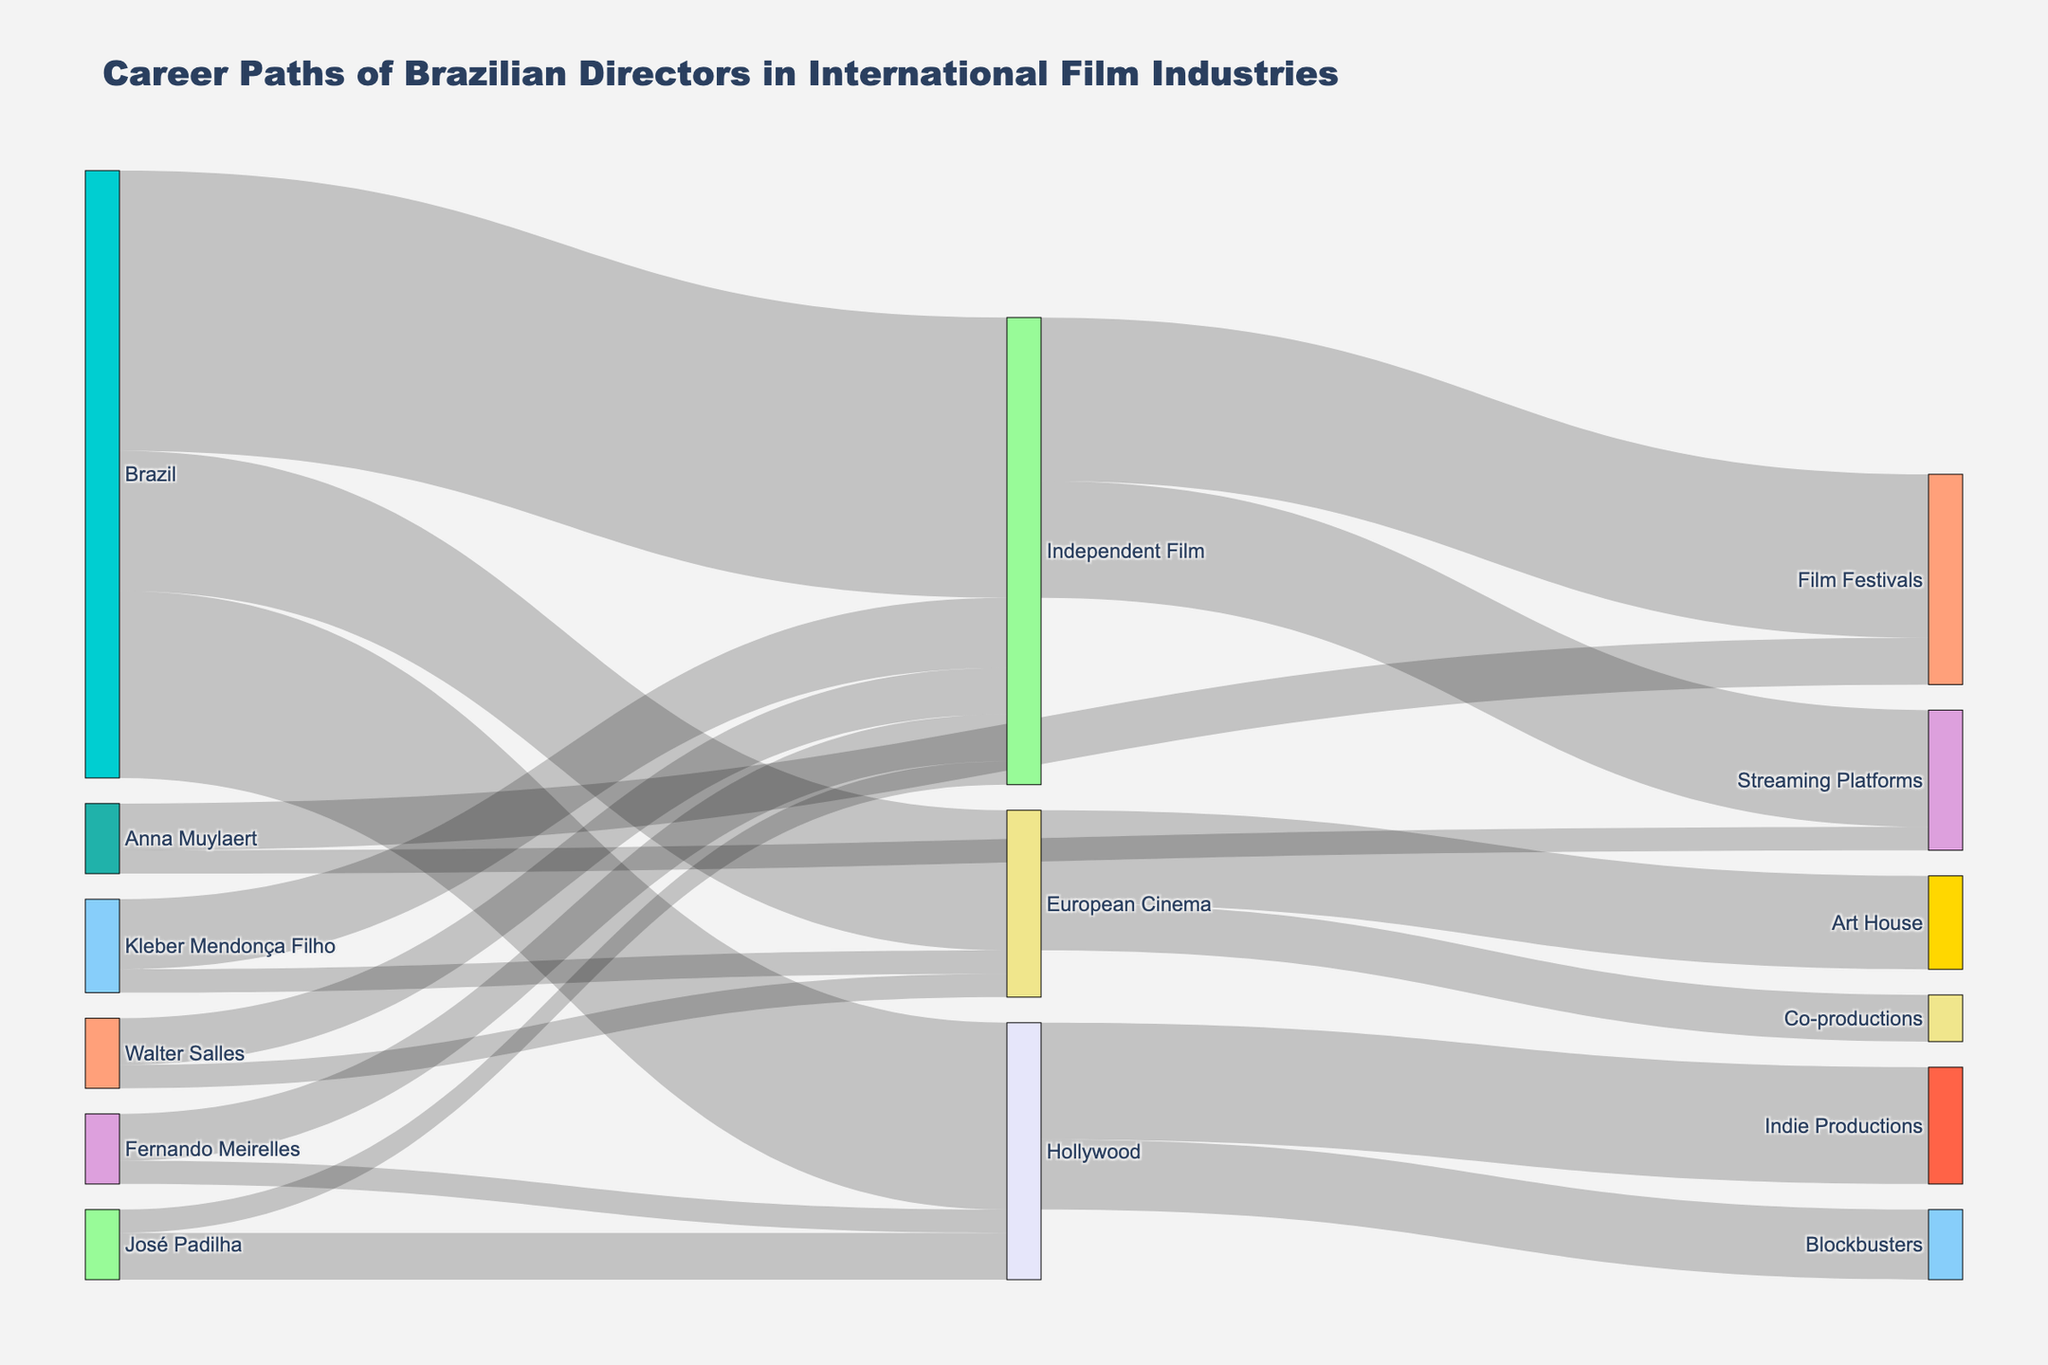What is the title of the Sankey diagram? The title is located at the top of the figure and it reads "Career Paths of Brazilian Directors in International Film Industries".
Answer: Career Paths of Brazilian Directors in International Film Industries How many Brazilian directors moved to Hollywood? The link between the nodes "Brazil" and "Hollywood" has a value of 8, indicating that 8 Brazilian directors moved to Hollywood.
Answer: 8 What color represents the "Independent Film" node? Each node in the Sankey diagram is represented by a specific color. "Independent Film" is identified by its unique color, which in the figure is light blue, similar to '#87CEFA'.
Answer: light blue How many Brazilian directors are associated with the European Cinema? The link between "Brazil" and "European Cinema" shows a value of 6, indicating that 6 Brazilian directors are connected to European Cinema.
Answer: 6 What is the total number of Brazilian directors who transitioned to other film industries? Sum the values of transitions from "Brazil" to "Hollywood", "European Cinema", and "Independent Film". So, 8 (to Hollywood) + 6 (to European Cinema) + 12 (to Independent Film) = 26.
Answer: 26 How many career paths lead from "Independent Film" to other categories? Sum the values of transitions from "Independent Film" to its connected categories: "Film Festivals" and "Streaming Platforms". So, 7 (to Film Festivals) + 5 (to Streaming Platforms) = 12.
Answer: 12 What is the combined value of directors associated with Fernando Meirelles and Walter Salles? Sum the values of transitions involving Fernando Meirelles and Walter Salles: 1+2 (Meirelles) + 1+2 (Salles) = 6.
Answer: 6 Who has a higher number of direct connections: Walter Salles or Kleber Mendonça Filho? Compare the values of connections for each director. Walter Salles has 3 connections total (1 to European Cinema + 2 to Independent Film), while Kleber Mendonça Filho has 4 (1 to European Cinema + 3 to Independent Film).
Answer: Kleber Mendonça Filho Which film industry has the least number of Brazilian directors moving to it from Brazil? Compare the values for transitions directly from "Brazil". The values show: 8 to Hollywood, 6 to European Cinema, 12 to Independent Film. Therefore, European Cinema has the least.
Answer: European Cinema Which category received the greatest flow from Hollywood? Check the links originating from Hollywood and compare their values. The values are 3 (to Blockbusters) and 5 (to Indie Productions), the greatest flow is into Indie Productions.
Answer: Indie Productions To which two categories did Fernando Meirelles transition? Look at the links involving Fernando Meirelles and see where the transitions end. The diagram shows transitions to "Hollywood" (1) and "Independent Film" (2).
Answer: Hollywood and Independent Film 